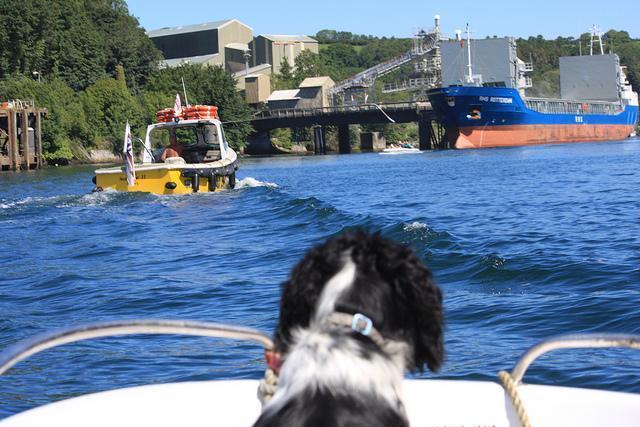How many boats are in the picture?
Give a very brief answer. 3. 